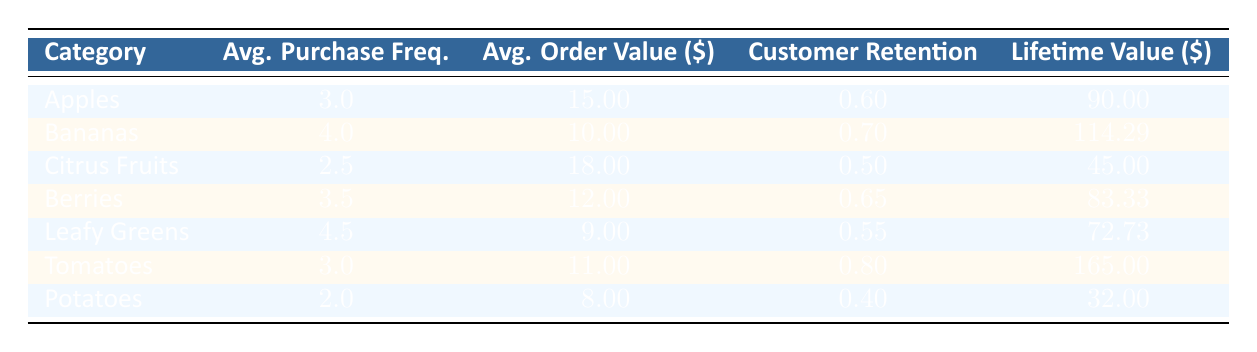What is the average purchase frequency for Bananas? The average purchase frequency for Bananas is stated directly in the table under the relevant column for the category. It is indicated as 4.0.
Answer: 4.0 Which produce category has the highest customer retention rate? Looking at the customer retention rates in the table for each category, Tomatoes has the highest retention rate of 0.80 compared to others.
Answer: Tomatoes What is the lifetime value of Citrus Fruits? The lifetime value of Citrus Fruits is provided in the table under the lifetime value column, which states it as 45.00.
Answer: 45.00 What is the average order value for all produce categories combined? To find the average order value, add the average order values of all categories: (15.00 + 10.00 + 18.00 + 12.00 + 9.00 + 11.00 + 8.00) = 83.00. There are 7 categories, so the average is 83.00 / 7 = 11.86.
Answer: 11.86 Do Berries have a higher lifetime value than Apples? Comparing the lifetime values provided in the table, Berries have a lifetime value of 83.33, while Apples have a value of 90.00. Thus, Berries do not exceed Apples' lifetime value.
Answer: No Which produce category has the lowest average purchase frequency and what is that value? The table indicates the average purchase frequencies, and Potatoes show the lowest value at 2.0.
Answer: Potatoes, 2.0 If a customer purchases Leafy Greens, what would be their spending based on the average order value? The average order value for Leafy Greens is listed as 9.00, which indicates that a customer spends on average 9.00 every time they order this category.
Answer: 9.00 What is the sum of lifetime values for all produce categories except Potatoes? To find this, sum the lifetime values of all categories first then subtract Potatoes: (90.00 + 114.29 + 45.00 + 83.33 + 72.73 + 165.00) = 570.35, then subtracting 32.00 gives 570.35 - 32.00 = 538.35.
Answer: 538.35 Which produce category, alongside Tomatoes, has an average order value greater than 10? Looking at Tomatoes with an average order value of 11.00, check the other categories. Bananas (10.00) and Citrus Fruits (18.00) are the other categories; however, only Citrus Fruits exceeds 10.00.
Answer: Citrus Fruits 